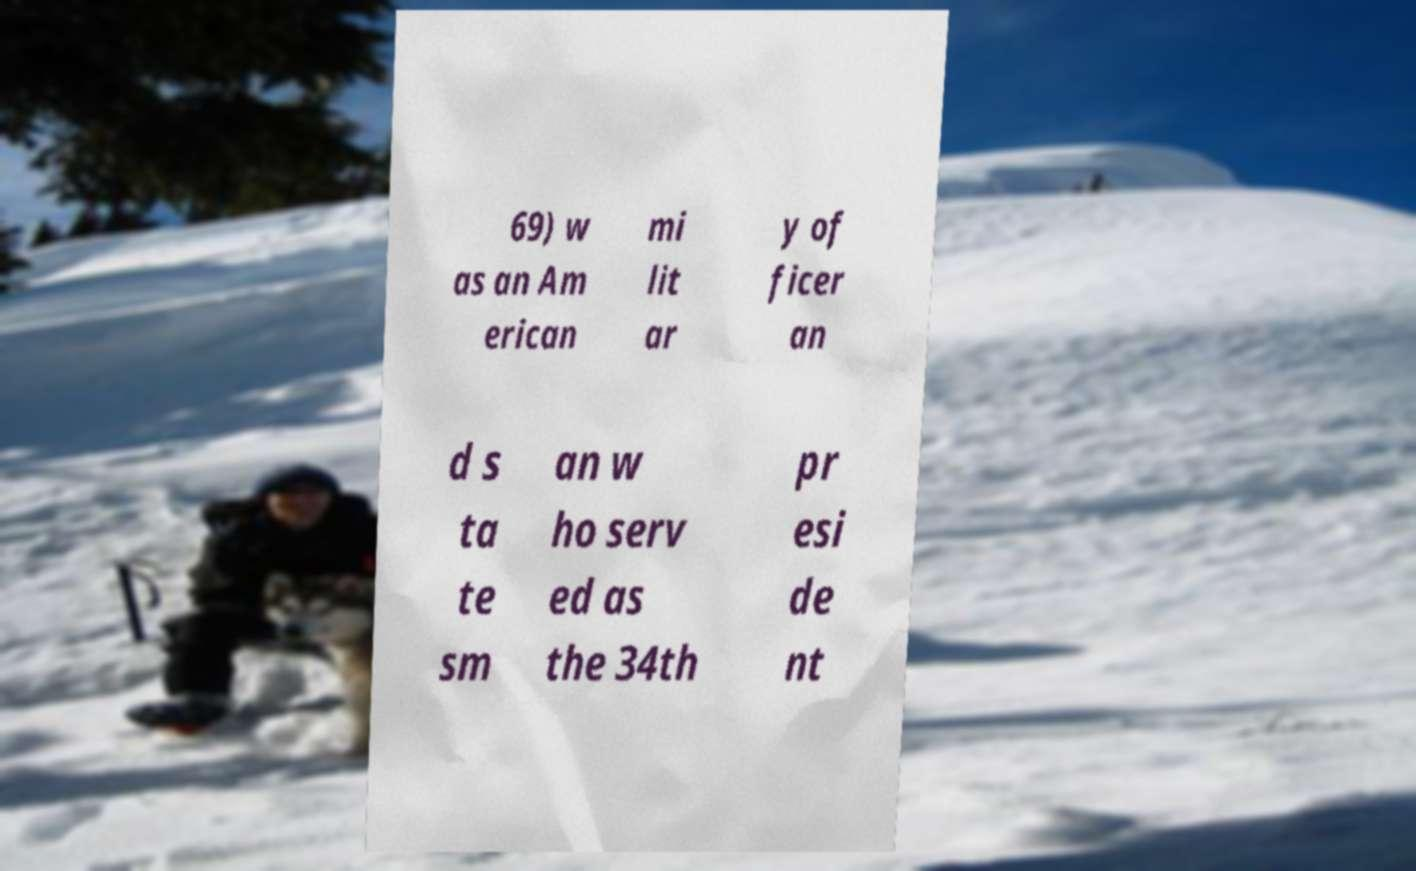I need the written content from this picture converted into text. Can you do that? 69) w as an Am erican mi lit ar y of ficer an d s ta te sm an w ho serv ed as the 34th pr esi de nt 